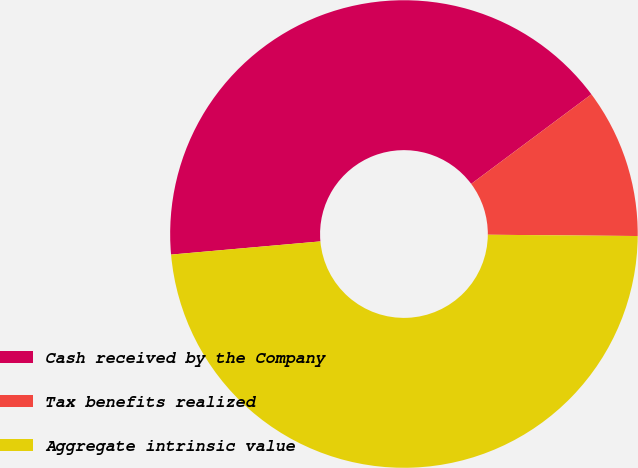<chart> <loc_0><loc_0><loc_500><loc_500><pie_chart><fcel>Cash received by the Company<fcel>Tax benefits realized<fcel>Aggregate intrinsic value<nl><fcel>41.21%<fcel>10.33%<fcel>48.46%<nl></chart> 